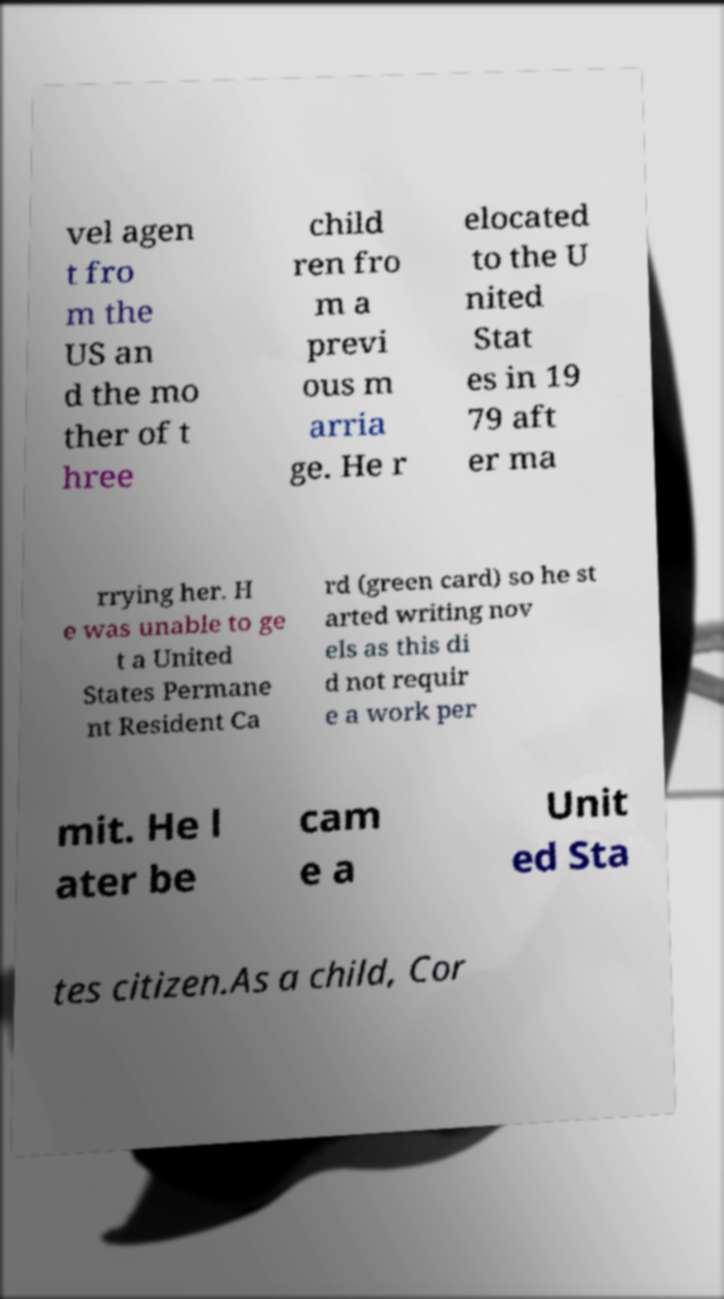Please read and relay the text visible in this image. What does it say? vel agen t fro m the US an d the mo ther of t hree child ren fro m a previ ous m arria ge. He r elocated to the U nited Stat es in 19 79 aft er ma rrying her. H e was unable to ge t a United States Permane nt Resident Ca rd (green card) so he st arted writing nov els as this di d not requir e a work per mit. He l ater be cam e a Unit ed Sta tes citizen.As a child, Cor 